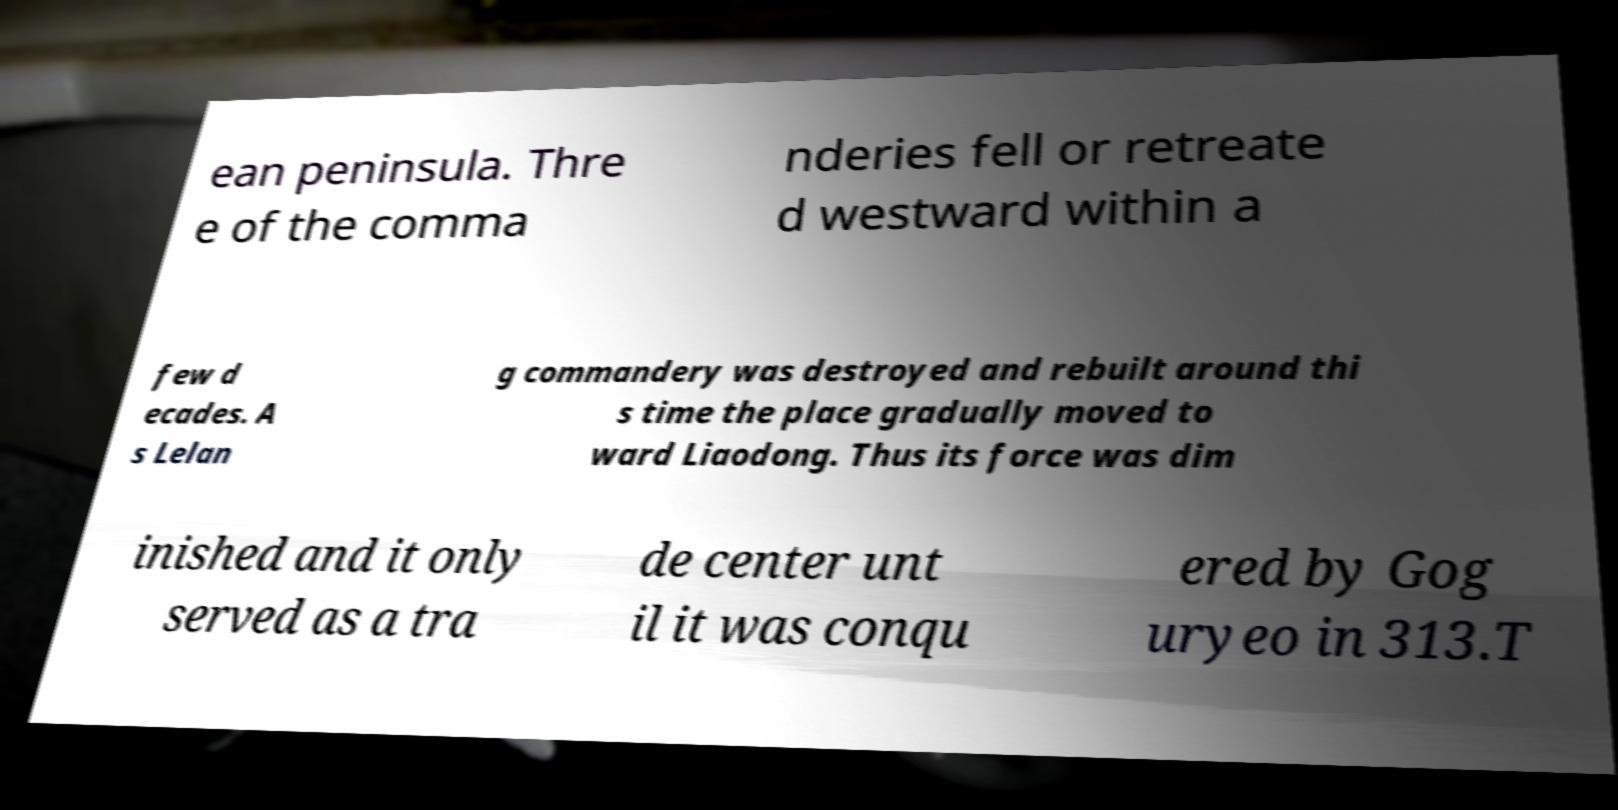Could you extract and type out the text from this image? ean peninsula. Thre e of the comma nderies fell or retreate d westward within a few d ecades. A s Lelan g commandery was destroyed and rebuilt around thi s time the place gradually moved to ward Liaodong. Thus its force was dim inished and it only served as a tra de center unt il it was conqu ered by Gog uryeo in 313.T 